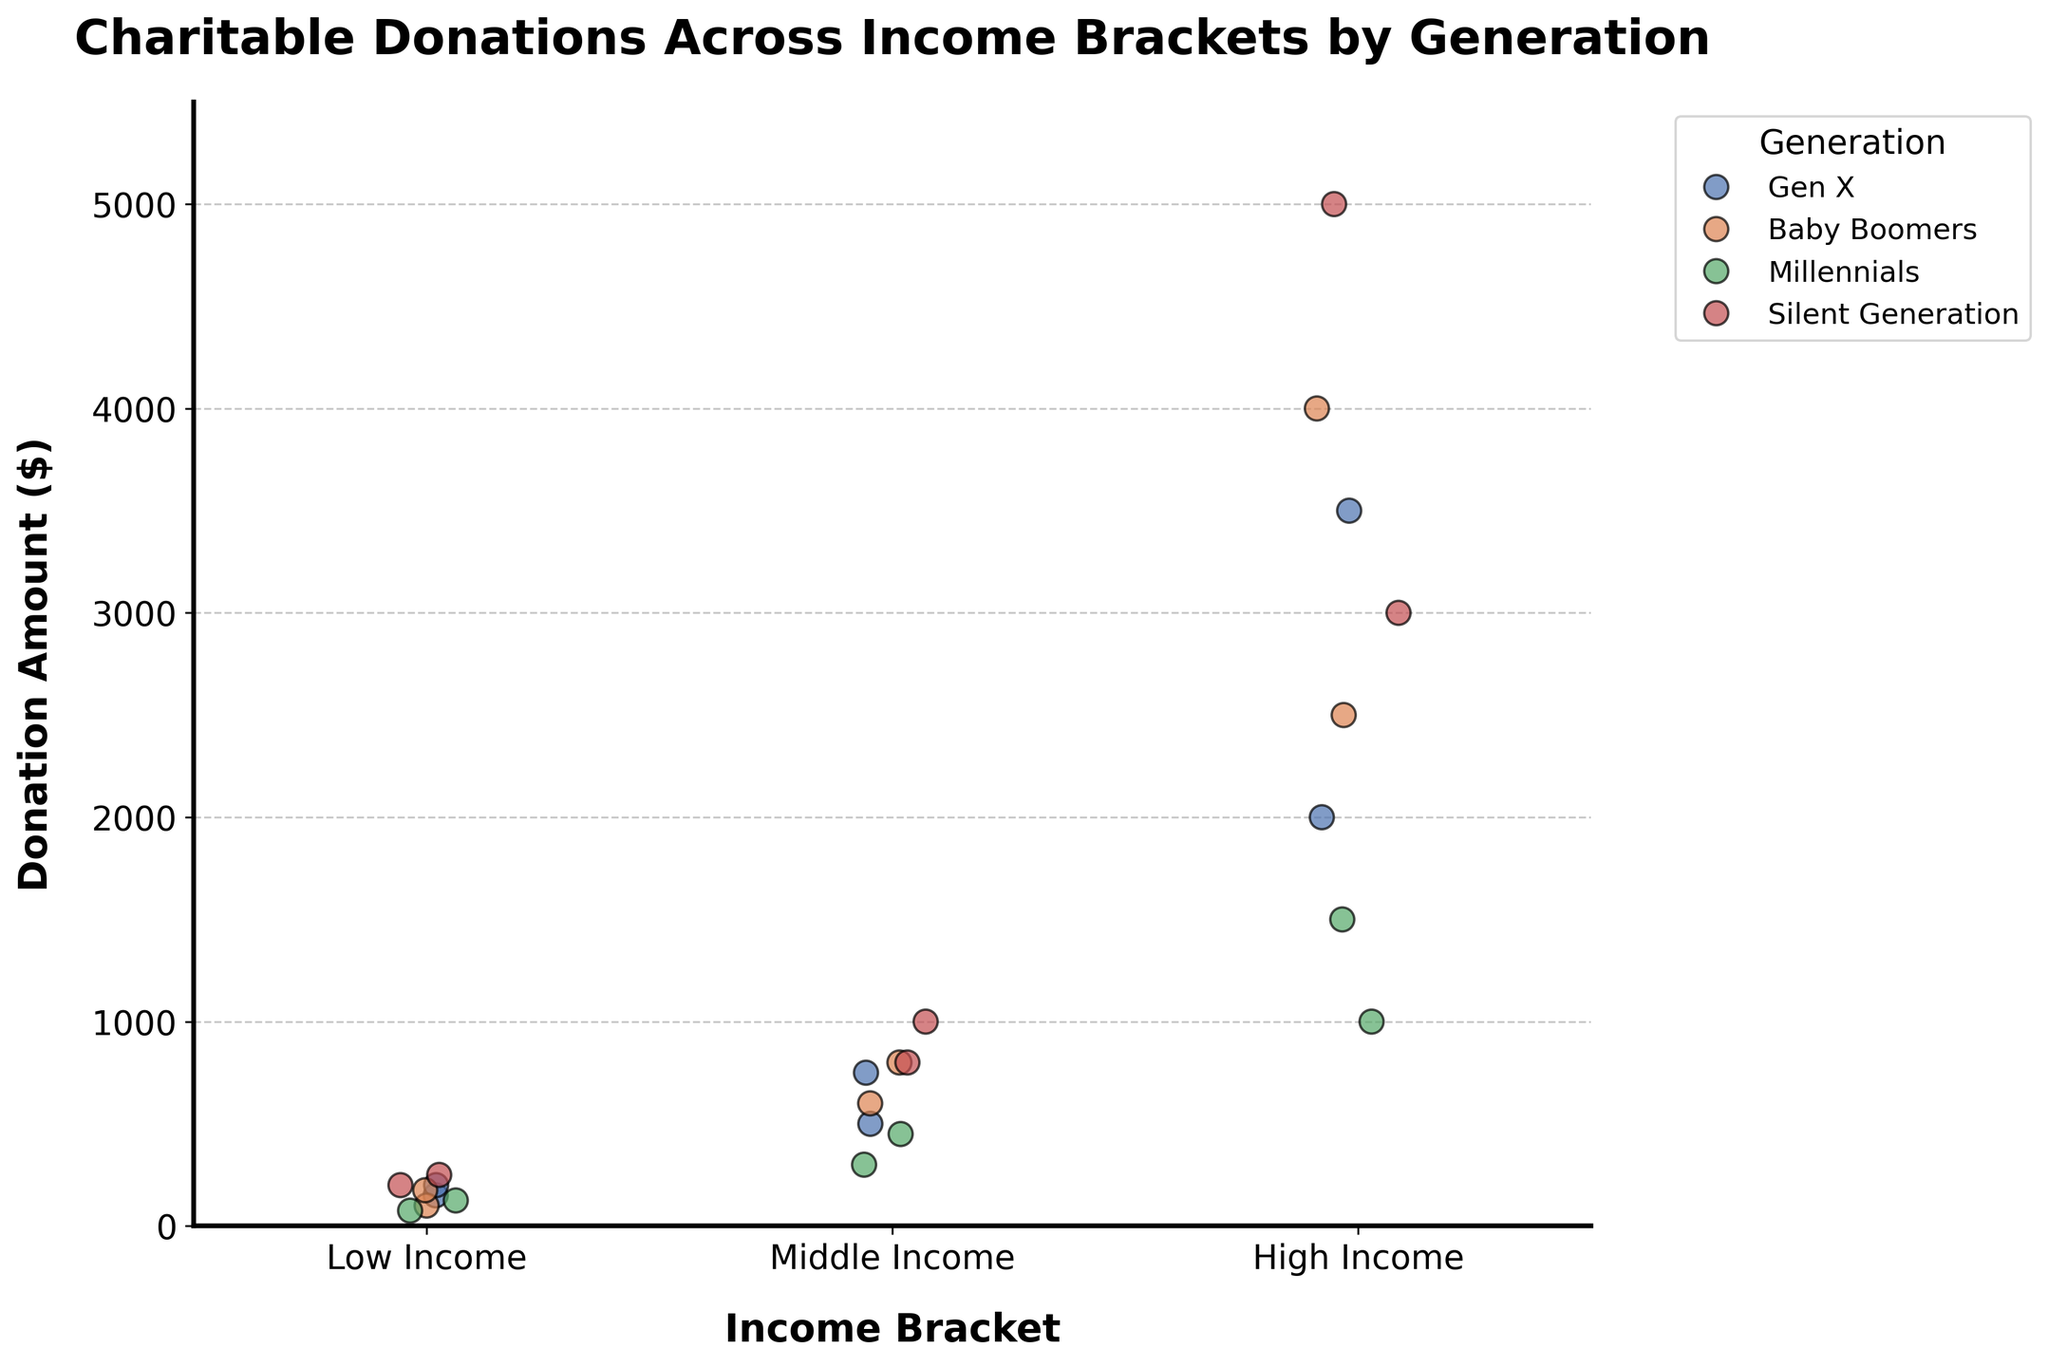What is the title of the figure? The title is typically located at the top of the figure and clearly indicates what the plot represents.
Answer: Charitable Donations Across Income Brackets by Generation Which generation has the highest single donation and what is the amount? By inspecting the scatter points on the plot, we can identify the highest point and see which color/legend it is associated with. The highest point belongs to the Silent Generation, and the amount is around $5000.
Answer: Silent Generation, $5000 How do Gen X'ers' donations compare to Baby Boomers in the High Income bracket? We need to look at the High Income bracket section of the plot and compare the vertical positions of the points associated with Gen X’ers and Baby Boomers. Gen X'ers have donations around $2000 and $3500, while Baby Boomers have $2500 and $4000. Generally, Baby Boomers have slightly higher donations.
Answer: Baby Boomers slightly higher Which generation has the most diverse range of donations in the High Income bracket? Look for the spread or range of data points along the y-axis in the High Income bracket section for each generation to determine which has the widest range. The Silent Generation shows the widest range from around $3000 to $5000.
Answer: Silent Generation On average, do Millennials donate more, less, or about the same as Gen X'ers in the Middle Income bracket? Calculate the average donation amount for both generations in the Middle Income bracket. Millennials have donations of $300 and $450, averaging $375. Gen X'ers have donations of $500 and $750, averaging $625. Thus, Gen X'ers donate more on average.
Answer: More Compare the spread of donations for the Low Income bracket across all generations. Which generation has the smallest spread? We compare the range of donation amounts for each generation in the Low Income bracket. The spread is the difference between the highest and lowest points for each generation. The smallest spread is among the Millennials, from $75 to $125, representing a spread of $50.
Answer: Millennials Which income bracket shows the largest maximum donation overall? Identify the highest donation amount for each income bracket. The High Income bracket has the largest maximum donation, which is $5000 by the Silent Generation.
Answer: High Income For which income bracket do Baby Boomers have their highest average donation? Calculate the average donation for Baby Boomers in each bracket by summing their donations and dividing by the number of donations. They donate $137.5 on average in Low Income, $700 in Middle Income, and $3250 in High Income. The highest average is thus in the High Income bracket.
Answer: High Income Do Gen X’ers and Millennials show similar or different donation patterns in the Low Income bracket? Compare the donation points for both generations in the Low Income bracket to see if they overlap. Gen X’ers have donations of $150 and $200, while Millennials have $75 and $125, indicating different patterns since they do not overlap.
Answer: Different Which generation seems to offer a more significant portion of their donations in the Middle Income bracket relative to other brackets? Observe the density and positioning of donations in the Middle Income bracket compared to other brackets for each generation. Gen X'ers and Baby Boomers have more concentrated donations in the Middle Income bracket, but Gen X'ers appear to spread these more significantly relative to their overall donation distribution.
Answer: Gen X'ers 